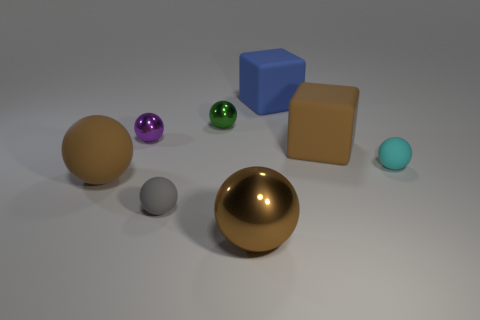What is the size of the brown thing that is the same shape as the blue matte object? The brown object, which has the same spherical shape as the matte blue sphere, appears to be quite large relative to the other objects in the image; it can be described as having a diameter roughly twice that of the blue sphere. 